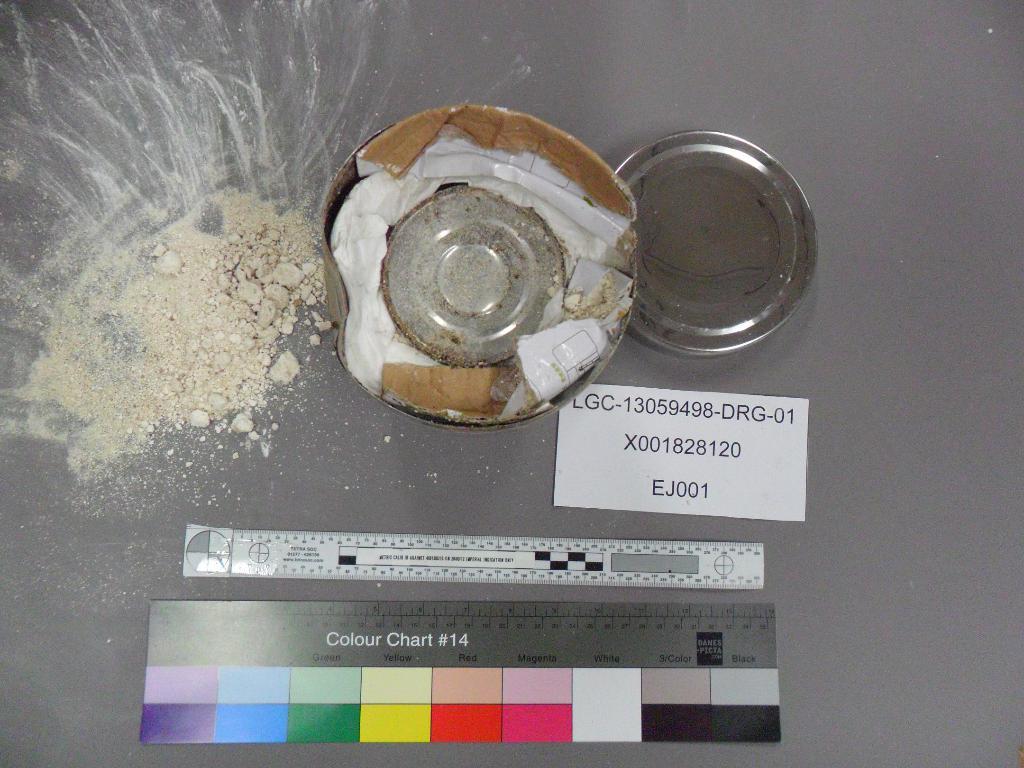What does the ruler say?
Keep it short and to the point. Colour chart #14. Is the number on the colour chart 14?
Provide a succinct answer. Yes. 